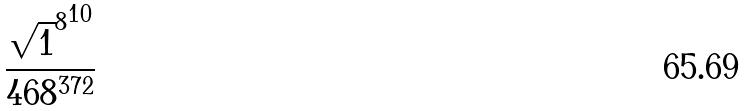<formula> <loc_0><loc_0><loc_500><loc_500>\frac { { \sqrt { 1 } ^ { 8 } } ^ { 1 0 } } { 4 6 8 ^ { 3 7 2 } }</formula> 